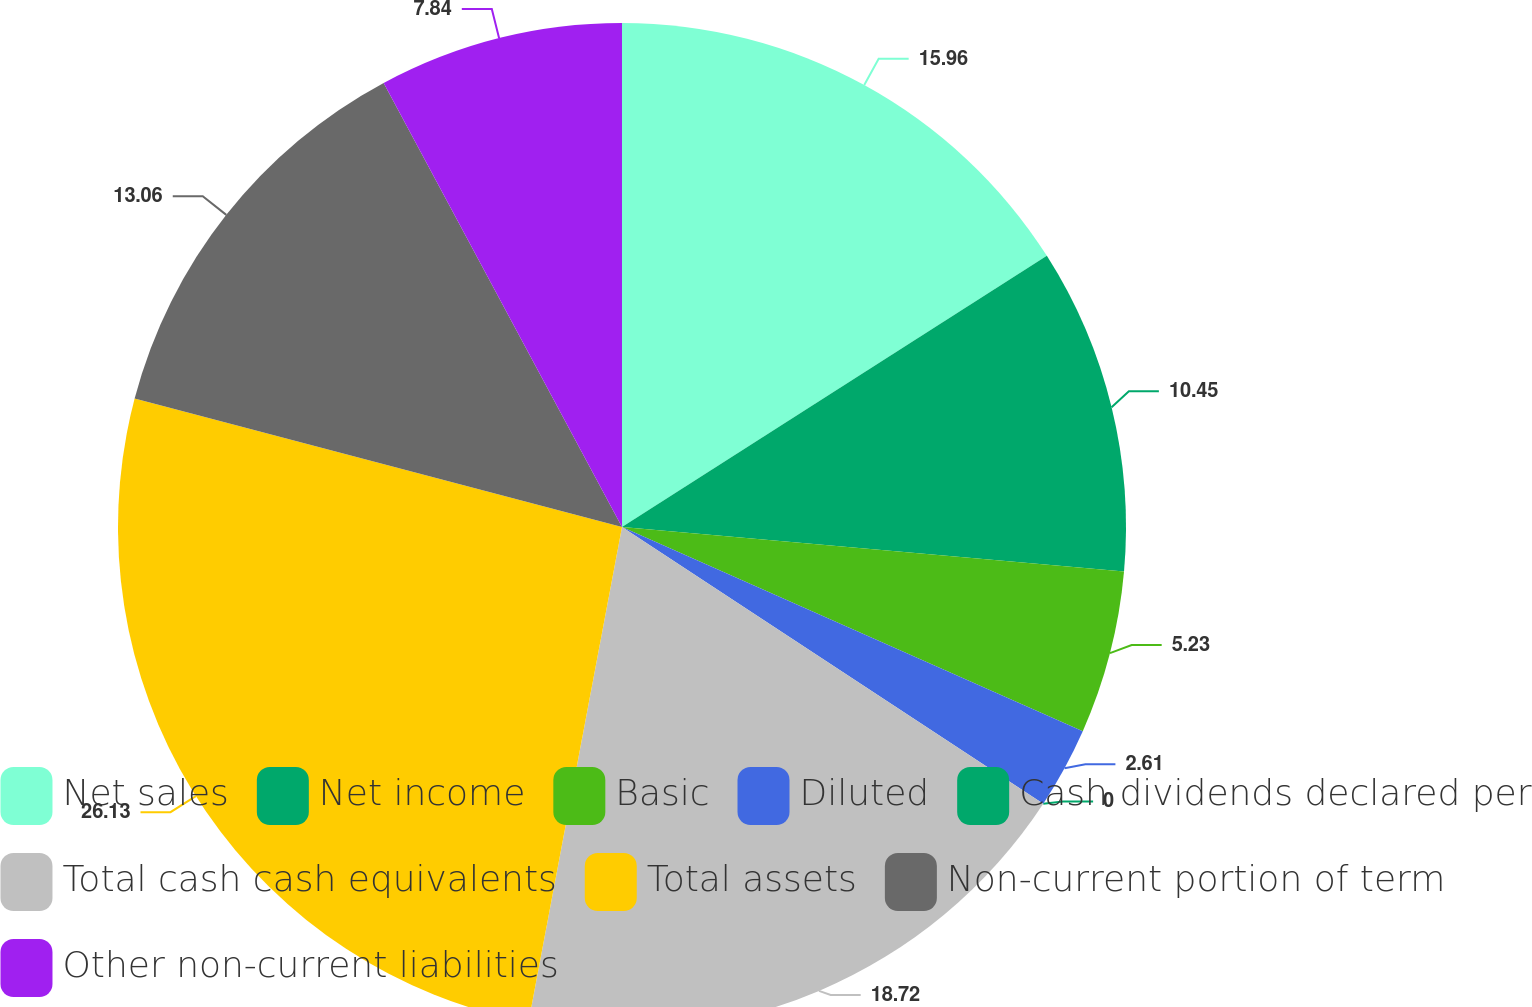Convert chart to OTSL. <chart><loc_0><loc_0><loc_500><loc_500><pie_chart><fcel>Net sales<fcel>Net income<fcel>Basic<fcel>Diluted<fcel>Cash dividends declared per<fcel>Total cash cash equivalents<fcel>Total assets<fcel>Non-current portion of term<fcel>Other non-current liabilities<nl><fcel>15.96%<fcel>10.45%<fcel>5.23%<fcel>2.61%<fcel>0.0%<fcel>18.72%<fcel>26.13%<fcel>13.06%<fcel>7.84%<nl></chart> 